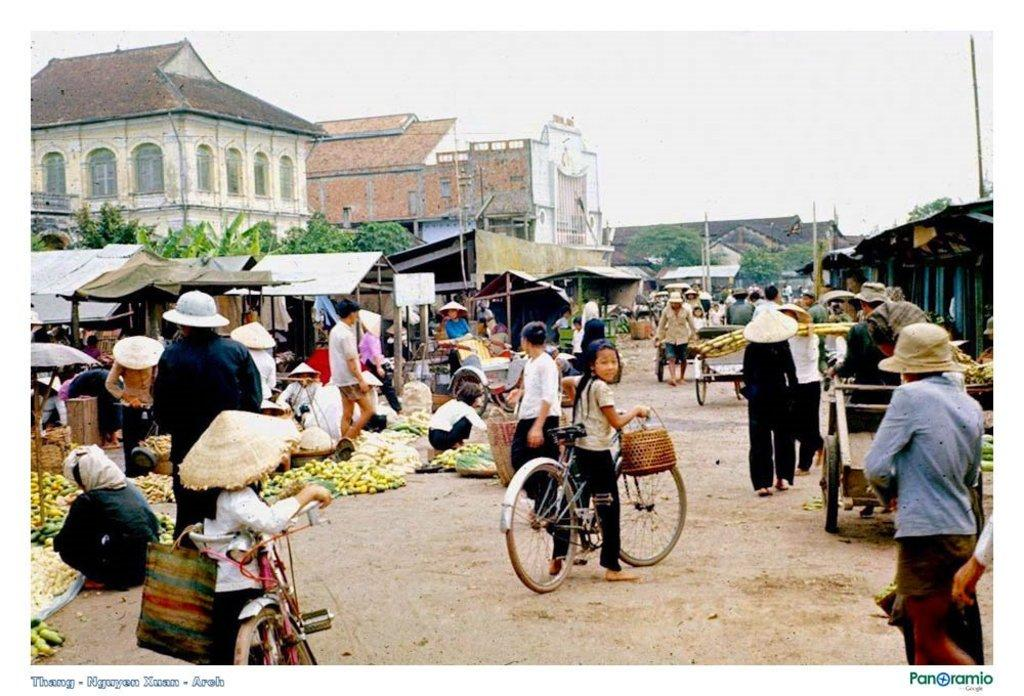What are the people in the image doing? The people in the image are buying fruits. Can you describe the children in the image? There are two children riding a bicycle in the image. What can be seen in the background of the image? There is a building, a tree, and the sky visible in the background of the image. What type of trail can be seen in the image? There is no trail present in the image. What side of the building is the tree located on? The image does not provide enough information to determine the exact location of the tree in relation to the building. 